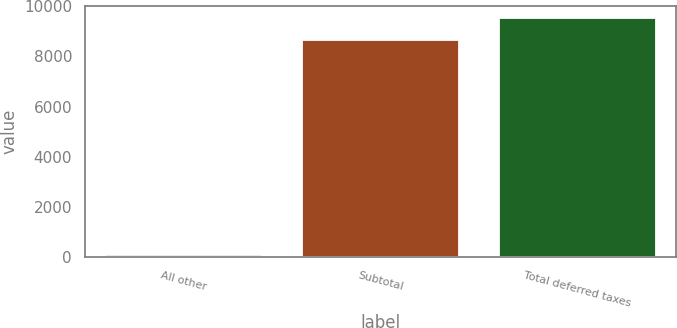<chart> <loc_0><loc_0><loc_500><loc_500><bar_chart><fcel>All other<fcel>Subtotal<fcel>Total deferred taxes<nl><fcel>82<fcel>8670<fcel>9528.8<nl></chart> 